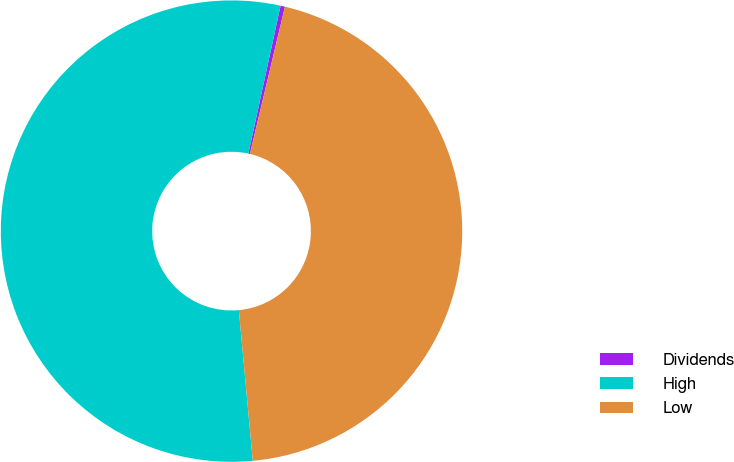<chart> <loc_0><loc_0><loc_500><loc_500><pie_chart><fcel>Dividends<fcel>High<fcel>Low<nl><fcel>0.31%<fcel>54.88%<fcel>44.81%<nl></chart> 